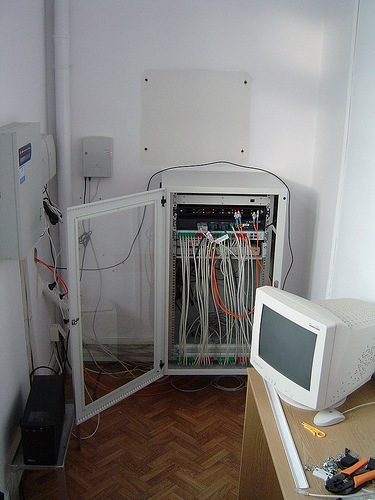<image>
Is the computer behind the wires? No. The computer is not behind the wires. From this viewpoint, the computer appears to be positioned elsewhere in the scene. Is there a monitor above the mouse? Yes. The monitor is positioned above the mouse in the vertical space, higher up in the scene. 